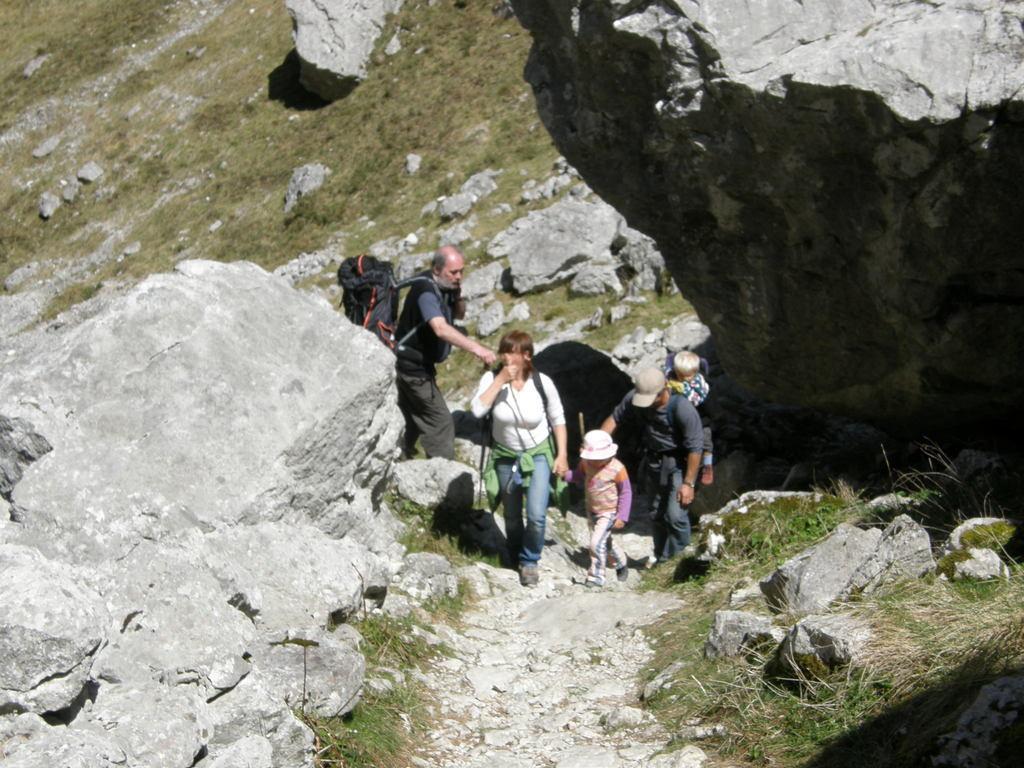Describe this image in one or two sentences. In this image I can see number of persons are standing on the rocky surface and I can see they are wearing bags. I can see some grass on the surface and in the background I can see a mountain. 